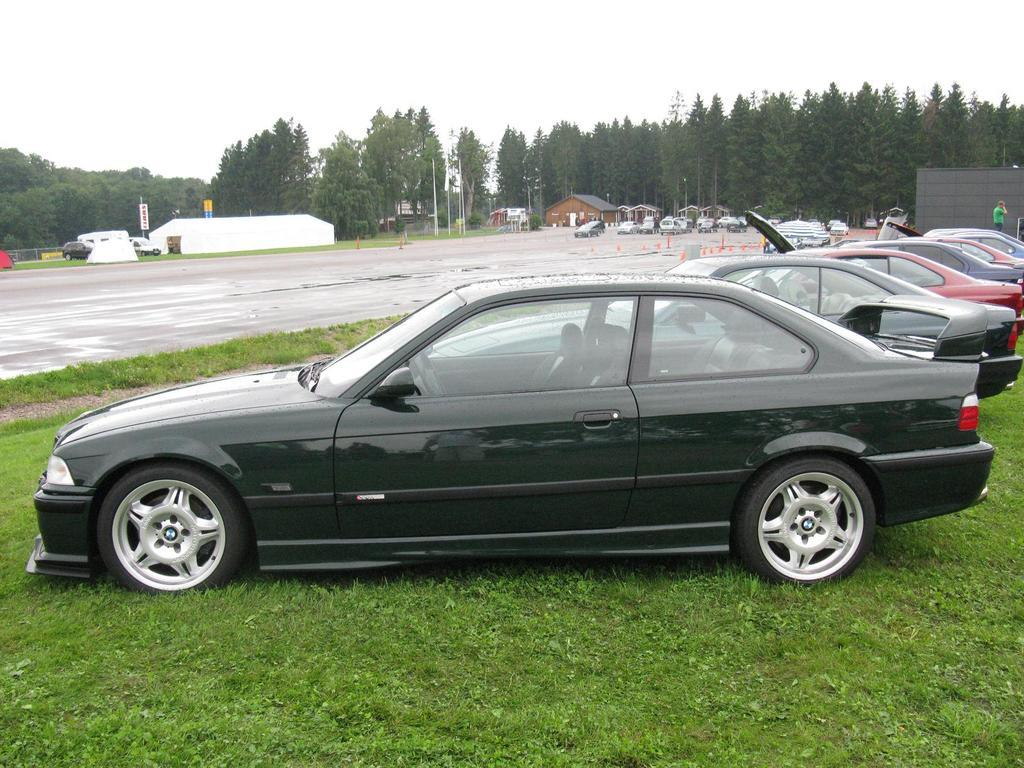What types of objects can be seen in the image? There are vehicles, a road, a wall, houses, boards, and trees visible in the image. What type of terrain is present in the image? There is grass in the image. Can you describe the setting of the image? The image features a road, houses, and trees, suggesting it might be a residential area. How many people are visible in the image? There is one person and a group of people visible in the image. What is visible in the background of the image? The sky is visible in the background of the image. What type of cattle can be seen grazing in the grass in the image? There are no cattle present in the image; it features vehicles, a road, a wall, houses, boards, and trees. What type of notebook is the person holding in the image? There is no notebook visible in the image; the person is not holding any object. 